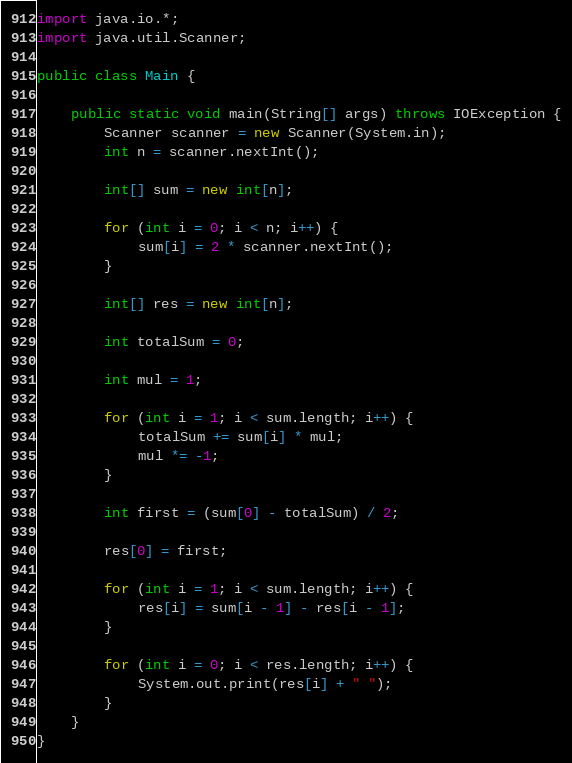Convert code to text. <code><loc_0><loc_0><loc_500><loc_500><_Java_>
import java.io.*;
import java.util.Scanner;

public class Main {

    public static void main(String[] args) throws IOException {
        Scanner scanner = new Scanner(System.in);
        int n = scanner.nextInt();

        int[] sum = new int[n];

        for (int i = 0; i < n; i++) {
            sum[i] = 2 * scanner.nextInt();
        }

        int[] res = new int[n];

        int totalSum = 0;

        int mul = 1;

        for (int i = 1; i < sum.length; i++) {
            totalSum += sum[i] * mul;
            mul *= -1;
        }

        int first = (sum[0] - totalSum) / 2;

        res[0] = first;

        for (int i = 1; i < sum.length; i++) {
            res[i] = sum[i - 1] - res[i - 1];
        }

        for (int i = 0; i < res.length; i++) {
            System.out.print(res[i] + " ");
        }
    }
}
</code> 